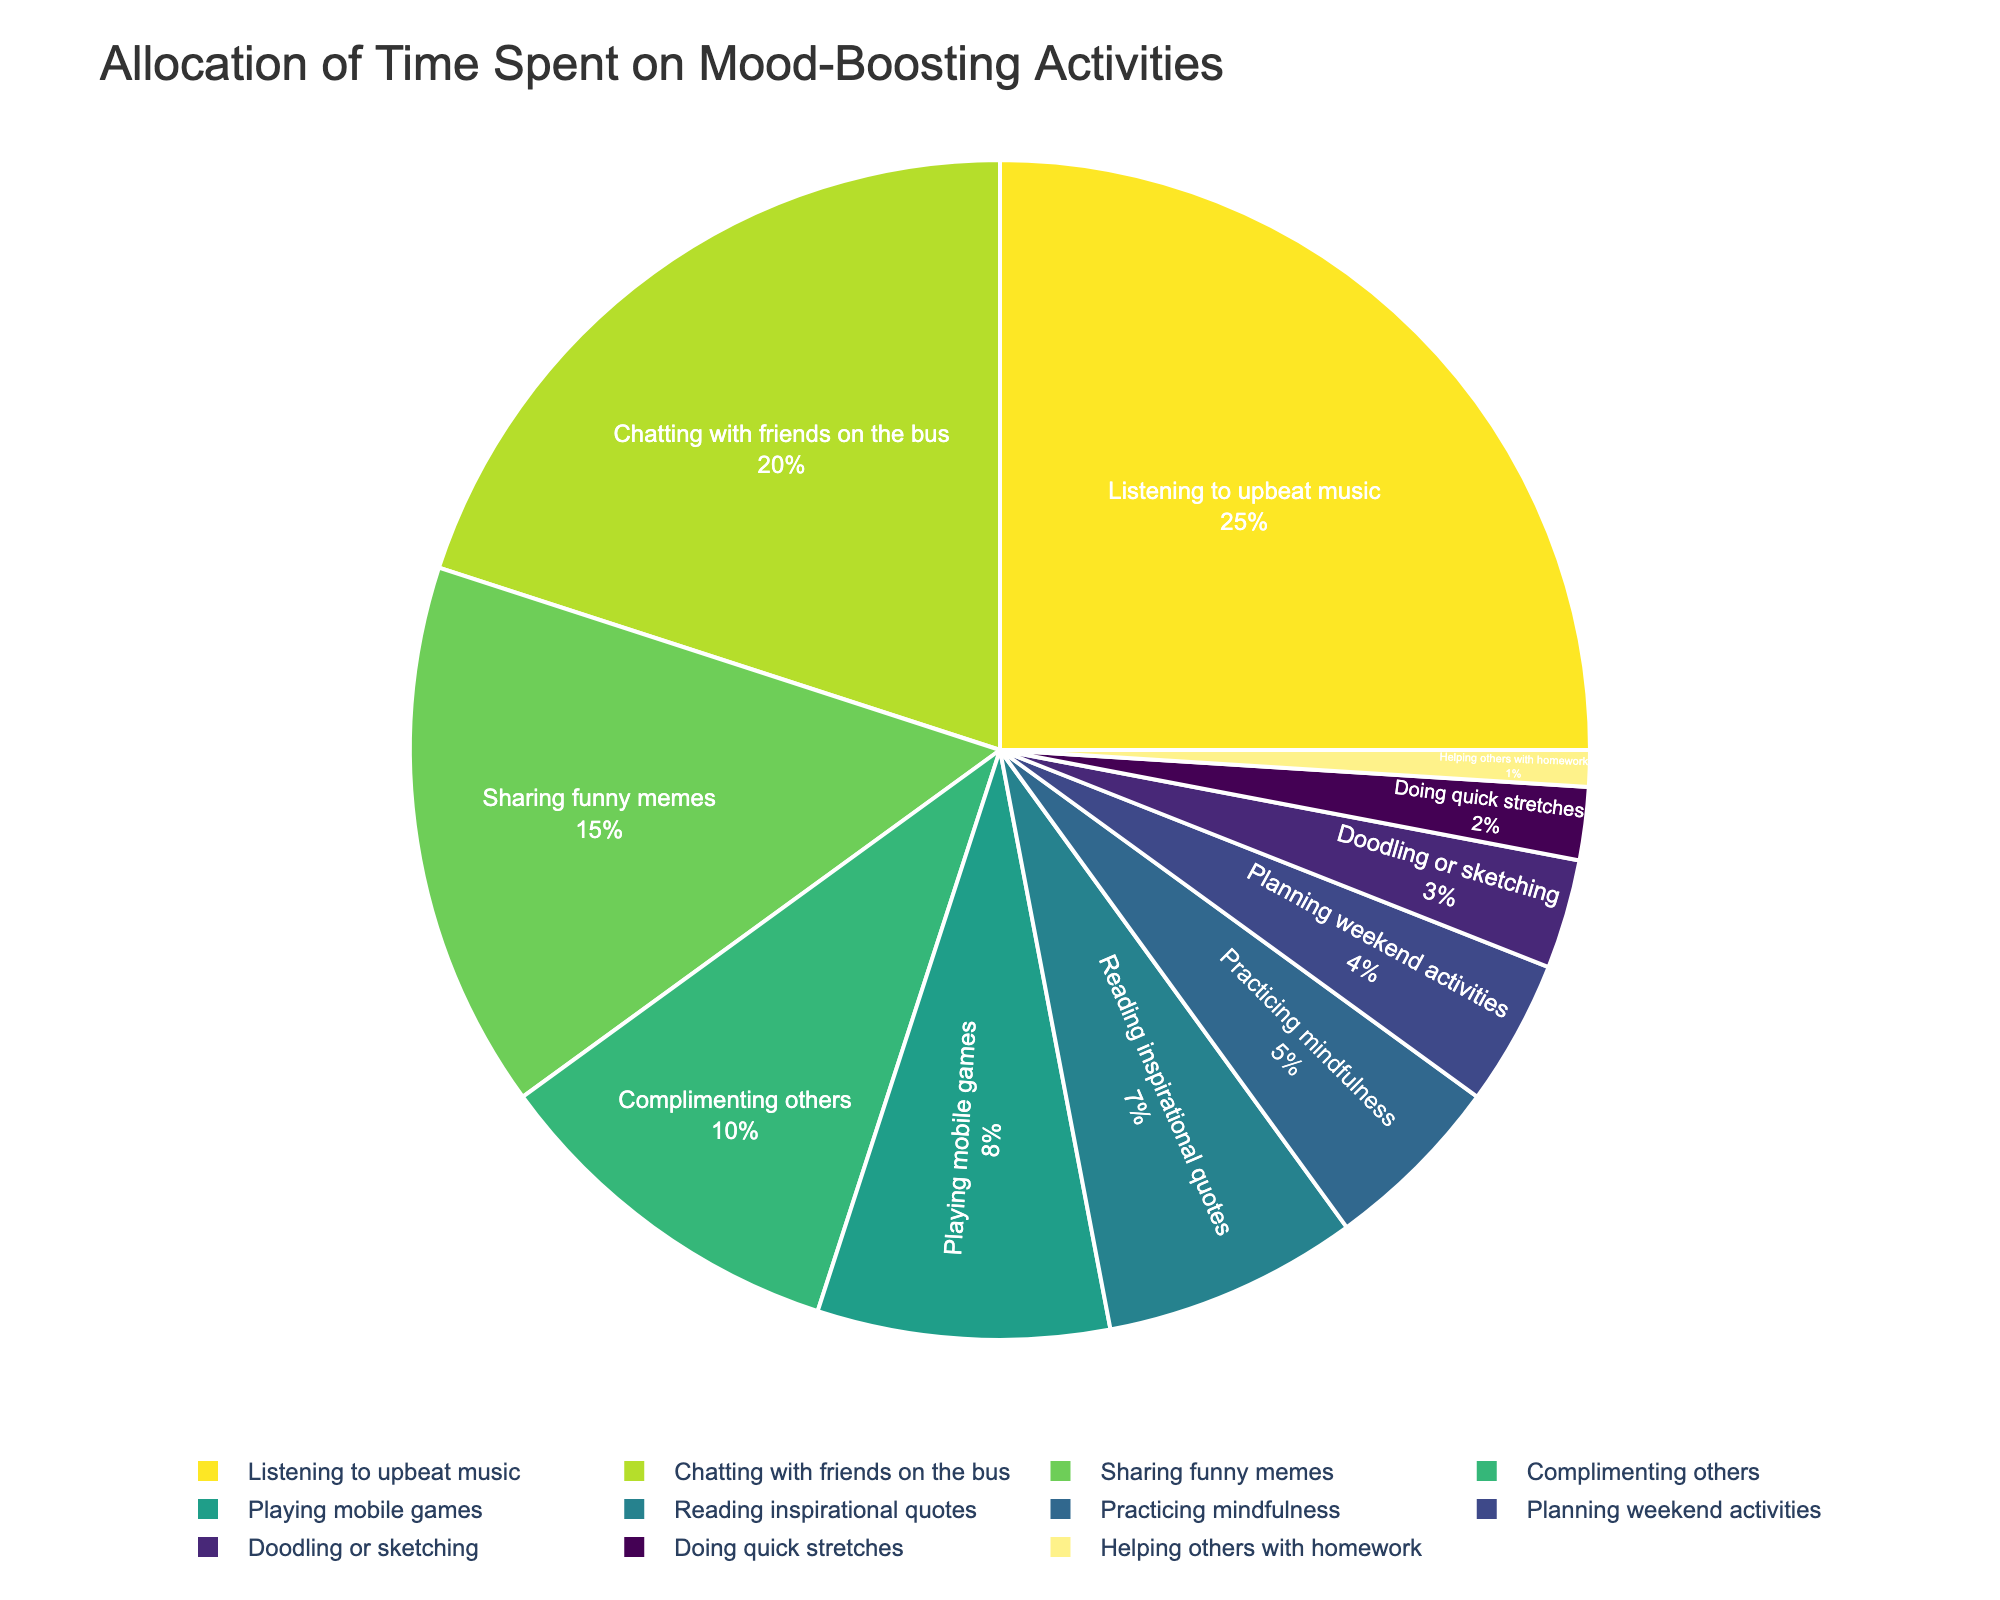What activity occupies the highest percentage of time? The activity with the highest percentage of time is the largest slice in the pie chart. Referring to the figure, "Listening to upbeat music" has the largest slice at 25%.
Answer: Listening to upbeat music Which two activities combined take up 35% of the time? Look at the two slices whose combined percentages sum to 35%. "Chatting with friends on the bus" (20%) and "Sharing funny memes" (15%) together make up 35%.
Answer: Chatting with friends on the bus and Sharing funny memes What is the total percentage for activities involving both social interaction and physical exercise? Identify the activities involving social interaction and physical exercise. "Chatting with friends on the bus" (20%), "Complimenting others" (10%), "Helping others with homework" (1%), and "Doing quick stretches" (2%). Adding them up: 20 + 10 + 1 + 2 = 33%.
Answer: 33% Which activity occupies a percentage that is less than half of the percentage for "Playing mobile games"? "Playing mobile games" occupies 8% of the time. Half of 8% is 4%. Any activity that is less than 4% is a correct answer. "Doodling or sketching" at 3% is less than 4%.
Answer: Doodling or sketching How much more time is spent on "Chatting with friends on the bus" compared to "Practicing mindfulness"? "Chatting with friends on the bus" occupies 20%, and "Practicing mindfulness" occupies 5%. Subtracting these percentages: 20 - 5 = 15%.
Answer: 15% What is the total percentage of time spent on activities that boost mood through creativity? Identify the creative activities: "Doodling or sketching" (3%) and "Reading inspirational quotes" (7%). Adding these percentages gives: 3 + 7 = 10%.
Answer: 10% What activities occupy percentages smaller than or equal to 3%? Look at the slices with percentages 3% or below. These are "Doodling or sketching" (3%), "Doing quick stretches" (2%), and "Helping others with homework" (1%).
Answer: Doodling or sketching, Doing quick stretches, Helping others with homework Which activity takes up the smallest slice on the pie chart? The smallest slice on the pie chart corresponds to the smallest percentage. "Helping others with homework" at 1% is the smallest slice.
Answer: Helping others with homework What's the sum of the percentages of the top three most time-consuming activities? Identify the top three activities: "Listening to upbeat music" (25%), "Chatting with friends on the bus" (20%), and "Sharing funny memes" (15%). Summing these: 25 + 20 + 15 = 60%.
Answer: 60% Is the total time spent on "Reading inspirational quotes" more than the total time spent on "Practicing mindfulness" and "Planning weekend activities" combined? "Reading inspirational quotes" has 7%, while "Practicing mindfulness" and "Planning weekend activities" have 5% and 4%, respectively. Combined: 5 + 4 = 9%. Since 7% < 9%, the answer is no.
Answer: No 